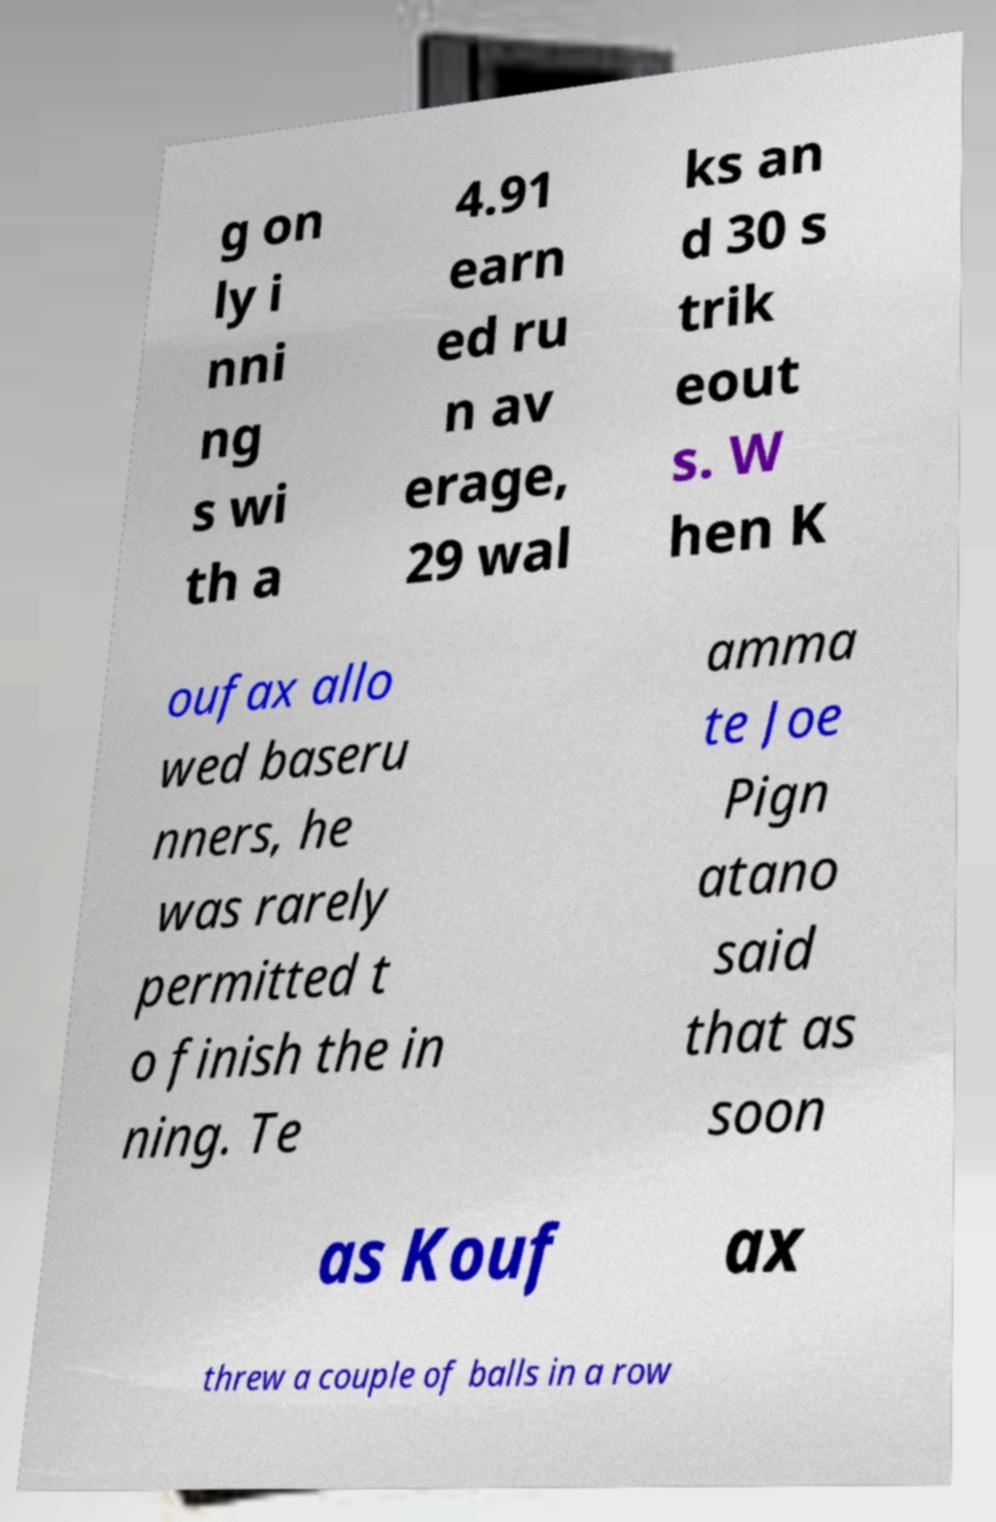Can you read and provide the text displayed in the image?This photo seems to have some interesting text. Can you extract and type it out for me? g on ly i nni ng s wi th a 4.91 earn ed ru n av erage, 29 wal ks an d 30 s trik eout s. W hen K oufax allo wed baseru nners, he was rarely permitted t o finish the in ning. Te amma te Joe Pign atano said that as soon as Kouf ax threw a couple of balls in a row 